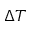Convert formula to latex. <formula><loc_0><loc_0><loc_500><loc_500>\Delta T</formula> 